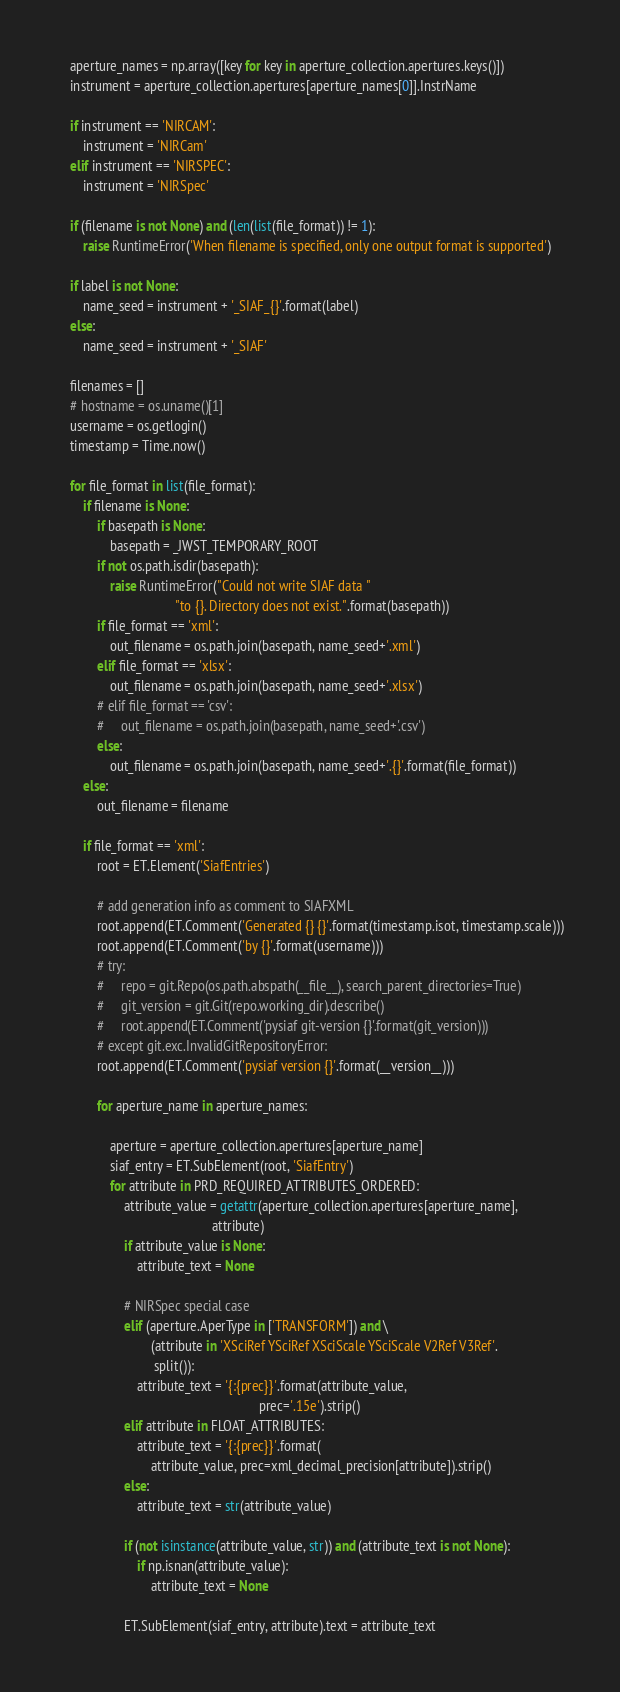Convert code to text. <code><loc_0><loc_0><loc_500><loc_500><_Python_>    aperture_names = np.array([key for key in aperture_collection.apertures.keys()])
    instrument = aperture_collection.apertures[aperture_names[0]].InstrName

    if instrument == 'NIRCAM':
        instrument = 'NIRCam'
    elif instrument == 'NIRSPEC':
        instrument = 'NIRSpec'

    if (filename is not None) and (len(list(file_format)) != 1):
        raise RuntimeError('When filename is specified, only one output format is supported')

    if label is not None:
        name_seed = instrument + '_SIAF_{}'.format(label)
    else:
        name_seed = instrument + '_SIAF'

    filenames = []
    # hostname = os.uname()[1]
    username = os.getlogin()
    timestamp = Time.now()

    for file_format in list(file_format):
        if filename is None:
            if basepath is None:
                basepath = _JWST_TEMPORARY_ROOT
            if not os.path.isdir(basepath):
                raise RuntimeError("Could not write SIAF data "
                                   "to {}. Directory does not exist.".format(basepath))
            if file_format == 'xml':
                out_filename = os.path.join(basepath, name_seed+'.xml')
            elif file_format == 'xlsx':
                out_filename = os.path.join(basepath, name_seed+'.xlsx')
            # elif file_format == 'csv':
            #     out_filename = os.path.join(basepath, name_seed+'.csv')
            else:
                out_filename = os.path.join(basepath, name_seed+'.{}'.format(file_format))
        else:
            out_filename = filename

        if file_format == 'xml':
            root = ET.Element('SiafEntries')

            # add generation info as comment to SIAFXML
            root.append(ET.Comment('Generated {} {}'.format(timestamp.isot, timestamp.scale)))
            root.append(ET.Comment('by {}'.format(username)))
            # try:
            #     repo = git.Repo(os.path.abspath(__file__), search_parent_directories=True)
            #     git_version = git.Git(repo.working_dir).describe()
            #     root.append(ET.Comment('pysiaf git-version {}'.format(git_version)))
            # except git.exc.InvalidGitRepositoryError:
            root.append(ET.Comment('pysiaf version {}'.format(__version__)))

            for aperture_name in aperture_names:

                aperture = aperture_collection.apertures[aperture_name]
                siaf_entry = ET.SubElement(root, 'SiafEntry')
                for attribute in PRD_REQUIRED_ATTRIBUTES_ORDERED:
                    attribute_value = getattr(aperture_collection.apertures[aperture_name],
                                              attribute)
                    if attribute_value is None:
                        attribute_text = None

                    # NIRSpec special case
                    elif (aperture.AperType in ['TRANSFORM']) and \
                            (attribute in 'XSciRef YSciRef XSciScale YSciScale V2Ref V3Ref'.
                             split()):
                        attribute_text = '{:{prec}}'.format(attribute_value,
                                                            prec='.15e').strip()
                    elif attribute in FLOAT_ATTRIBUTES:
                        attribute_text = '{:{prec}}'.format(
                            attribute_value, prec=xml_decimal_precision[attribute]).strip()
                    else:
                        attribute_text = str(attribute_value)

                    if (not isinstance(attribute_value, str)) and (attribute_text is not None):
                        if np.isnan(attribute_value):
                            attribute_text = None

                    ET.SubElement(siaf_entry, attribute).text = attribute_text
</code> 